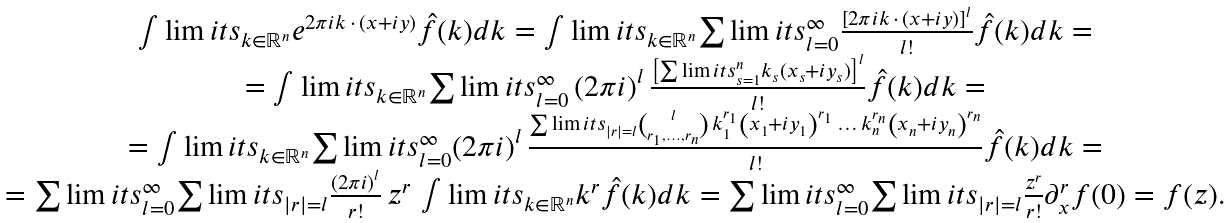Convert formula to latex. <formula><loc_0><loc_0><loc_500><loc_500>\begin{array} { c } \int \lim i t s _ { k \in \mathbb { R } ^ { n } } { e ^ { 2 \pi i k \, \cdot \, ( x + i y ) } \hat { f } ( k ) d k } = \int \lim i t s _ { k \in \mathbb { R } ^ { n } } { \sum \lim i t s _ { l = 0 } ^ { \infty } { \frac { \left [ { 2 \pi i k \, \cdot \, ( x + i y ) } \right ] ^ { l } } { l ! } } \hat { f } ( k ) d k } = \\ = \int \lim i t s _ { k \in \mathbb { R } ^ { n } } { \sum \lim i t s _ { l = 0 } ^ { \infty } \left ( { 2 \pi i } \right ) ^ { l } { \frac { \left [ { \sum \lim i t s _ { s = 1 } ^ { n } { k _ { s } ( x _ { s } + i y _ { s } ) } } \right ] ^ { l } } { l ! } } \hat { f } ( k ) d k } = \\ = \int \lim i t s _ { k \in \mathbb { R } ^ { n } } { \sum \lim i t s _ { l = 0 } ^ { \infty } { \left ( { 2 \pi i } \right ) ^ { l } \frac { \sum \lim i t s _ { | r | = l } { \binom { l } { r _ { 1 } , \dots , r _ { n } } \, k ^ { r _ { 1 } } _ { 1 } \left ( { x _ { 1 } + i y _ { 1 } } \right ) ^ { r _ { 1 } } \, \dots \, k ^ { r _ { n } } _ { n } \left ( { x _ { n } + i y _ { n } } \right ) ^ { r _ { n } } } } { l ! } } \hat { f } ( k ) d k } = \\ = \sum \lim i t s _ { l = 0 } ^ { \infty } { \sum \lim i t s _ { | r | = l } { \frac { \left ( { 2 \pi i } \right ) ^ { l } } { r ! } \, z ^ { r } \, \int \lim i t s _ { k \in \mathbb { R } ^ { n } } { k ^ { r } \hat { f } ( k ) d k } } } = \sum \lim i t s _ { l = 0 } ^ { \infty } { \sum \lim i t s _ { | r | = l } { \frac { z ^ { r } } { r ! } \partial _ { x } ^ { r } f ( 0 ) } } = f ( z ) . \end{array}</formula> 